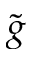<formula> <loc_0><loc_0><loc_500><loc_500>\tilde { g }</formula> 